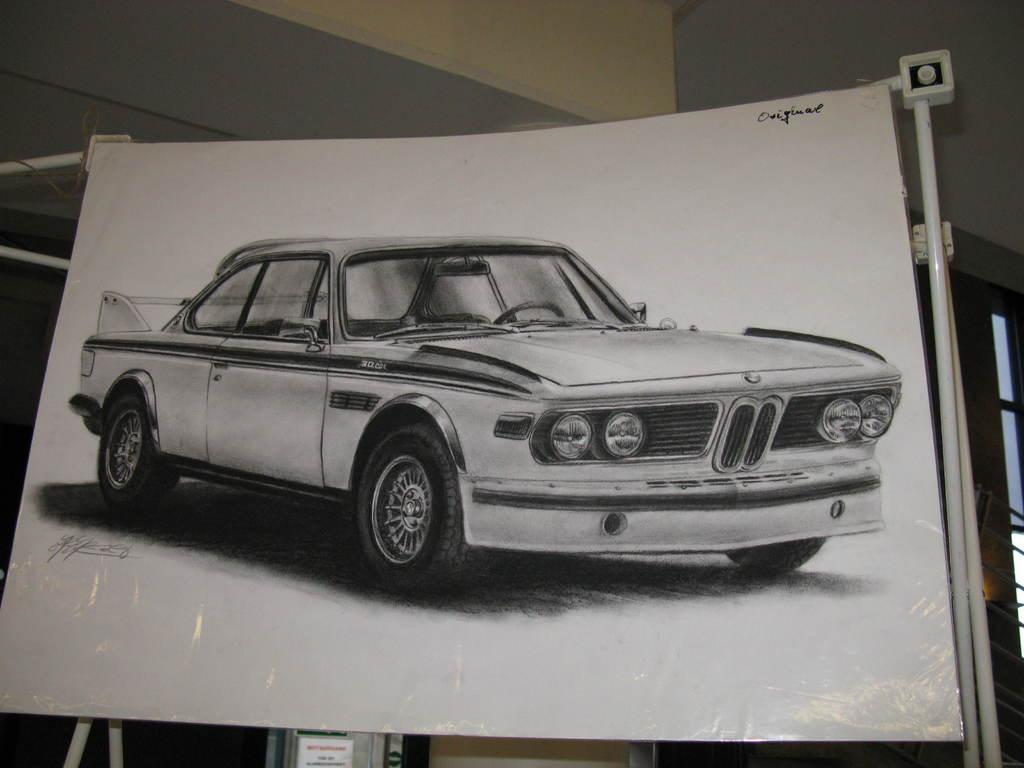What is the main subject of the image? There is a board in the image. What is depicted on the board? There is a vehicle depicted on the board. What can be seen in the background of the image? There is a wall visible in the background of the image, and there are objects present in the background as well. Can you tell me how many goats are standing on the vehicle in the image? There are no goats present in the image; the vehicle is depicted on a board. What type of hair is shown on the wall in the image? There is no hair shown on the wall in the image; only a vehicle is depicted on the board, and a wall is visible in the background. 